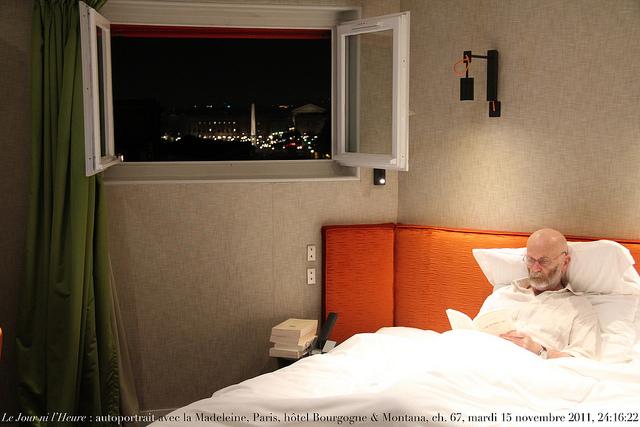How many pillows are there?
Write a very short answer. 2. Is the window open?
Short answer required. Yes. Is the sun shining through the window?
Quick response, please. No. Is the person in the bed wearing glasses?
Answer briefly. Yes. Yes it is open?
Write a very short answer. Yes. 